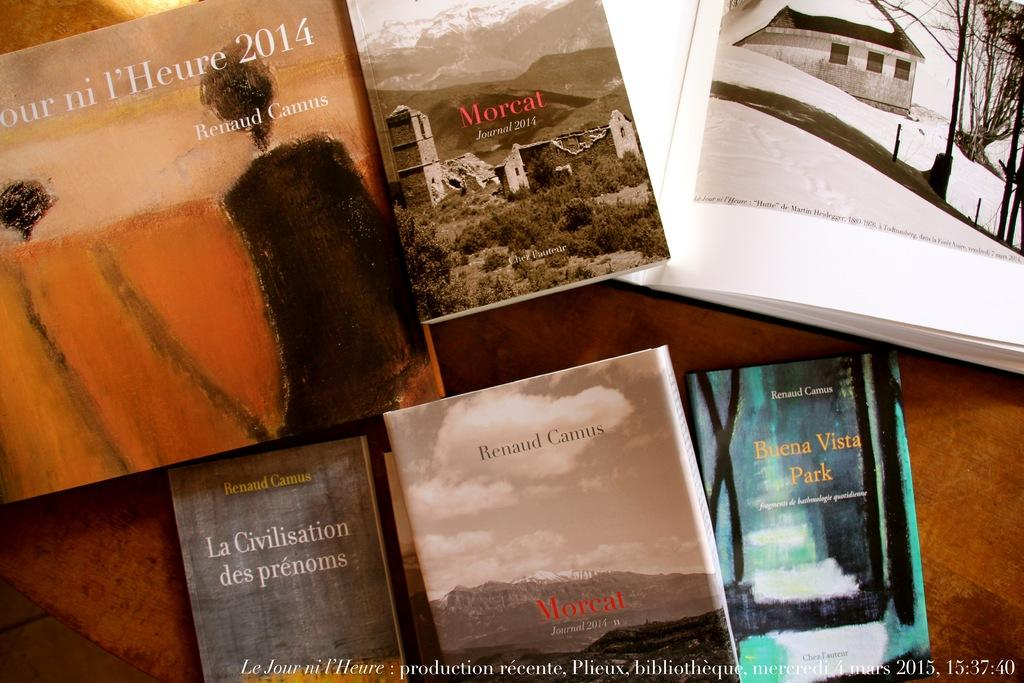Provide a one-sentence caption for the provided image. A variety of books by Renaud Camus including Buena Vista Park. 